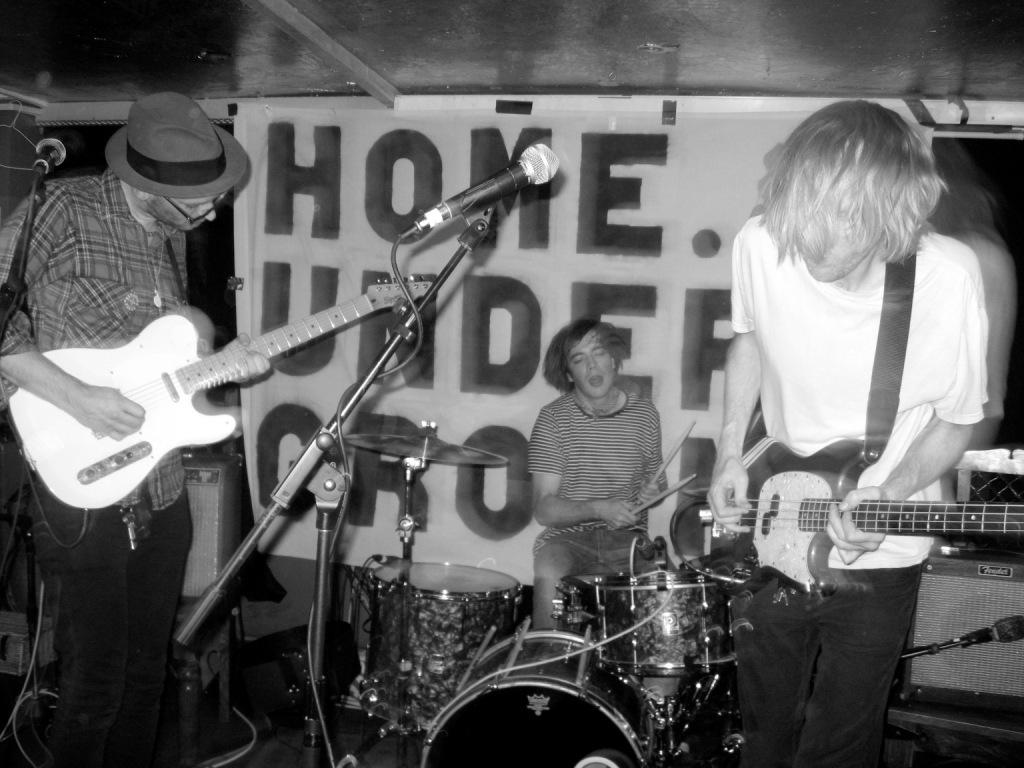How many people are in the image? There are three men in the image. What are two of the men doing in the image? Two of the men are playing guitars. What is the third man doing in the image? The third man is playing drums. What object is in front of the musicians? There is a microphone in front of the musicians. What can be seen in the background of the image? There is a banner in the background of the image. What type of shoes are the musicians wearing in the image? There is no information about the shoes the musicians are wearing in the image, so we cannot answer that question. 